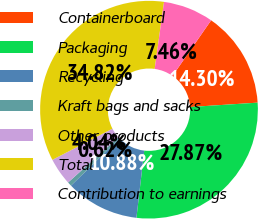Convert chart. <chart><loc_0><loc_0><loc_500><loc_500><pie_chart><fcel>Containerboard<fcel>Packaging<fcel>Recycling<fcel>Kraft bags and sacks<fcel>Other products<fcel>Total<fcel>Contribution to earnings<nl><fcel>14.3%<fcel>27.87%<fcel>10.88%<fcel>0.62%<fcel>4.04%<fcel>34.82%<fcel>7.46%<nl></chart> 